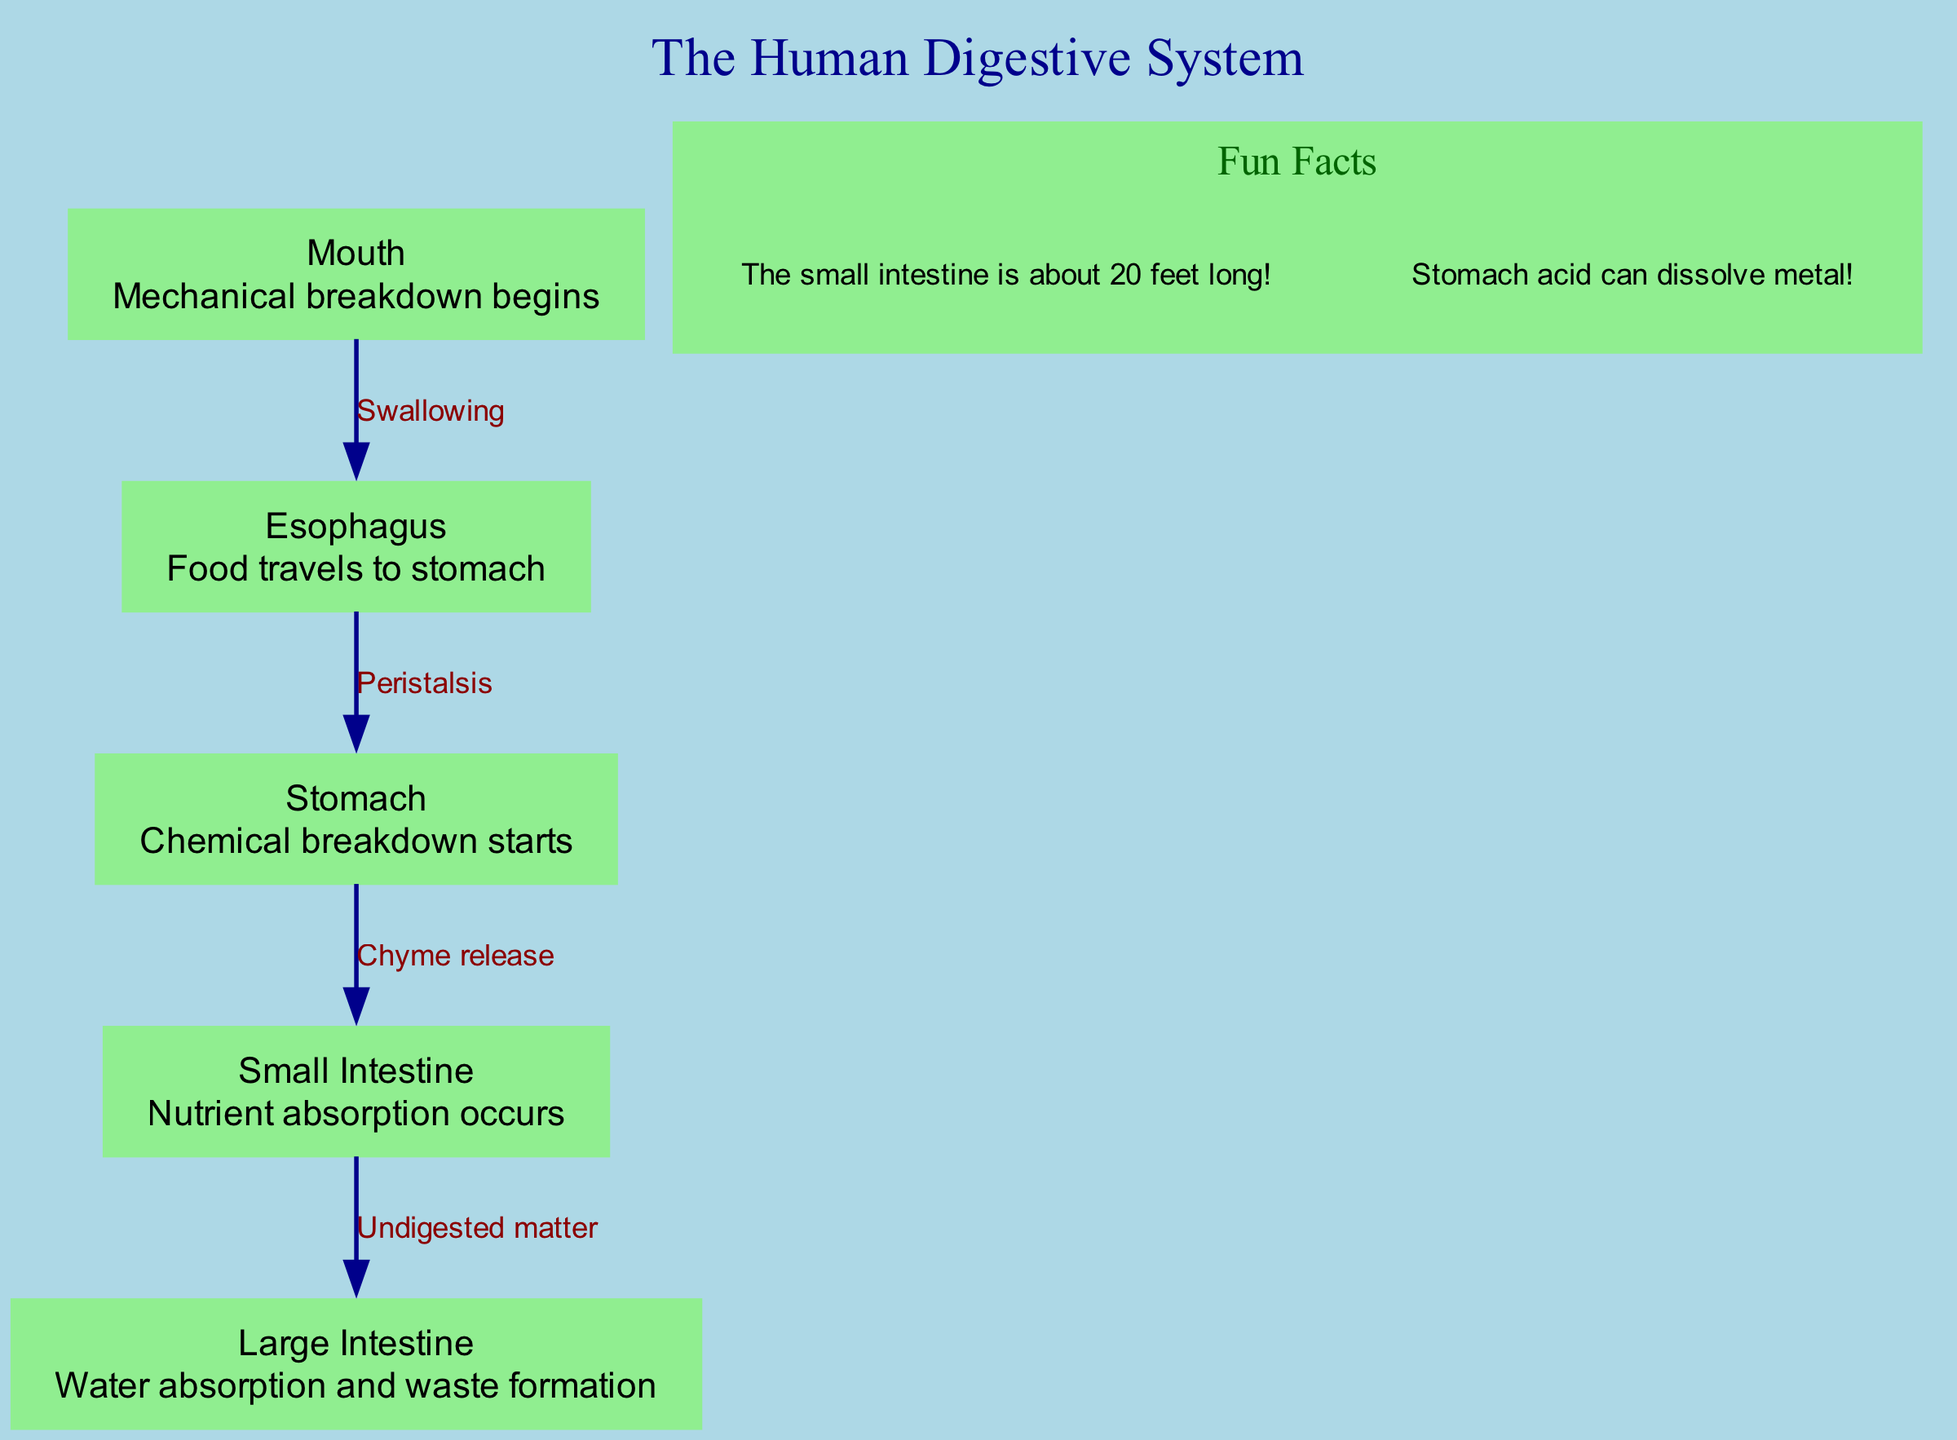What is the first organ in the digestive system? The diagram shows "Mouth" as the first organ in the flow of the digestive system. It's labeled at the start of the diagram.
Answer: Mouth What process occurs in the stomach? According to the diagram, the stomach is responsible for "Chemical breakdown starts," which is its primary function as shown.
Answer: Chemical breakdown How many nodes are present in the diagram? The diagram contains five nodes, which are Mouth, Esophagus, Stomach, Small Intestine, and Large Intestine. This can be counted directly from the node list.
Answer: 5 What is the relationship between the esophagus and the stomach? The diagram indicates that food moves from the Esophagus to the Stomach through the process labeled as "Peristalsis," which describes this connection.
Answer: Peristalsis Which organ is responsible for nutrient absorption? The Small Intestine is labeled in the diagram as the organ where "Nutrient absorption occurs," directly providing this information.
Answer: Small Intestine What is released from the stomach to the small intestine? The diagram states that "Chyme release" occurs from the Stomach to the Small Intestine, identifying this specific action.
Answer: Chyme release What happens in the large intestine? The diagram describes the Large Intestine's function as "Water absorption and waste formation," indicating its role in the digestive process.
Answer: Water absorption and waste formation What is the total number of edges in the diagram? By reviewing the edges present which connect the nodes, there are four edges in total defined by the relationships between the various organs.
Answer: 4 What is a fun fact about the small intestine? The diagram highlights a fun fact stating "The small intestine is about 20 feet long!" which provides an interesting piece of information about it.
Answer: The small intestine is about 20 feet long 